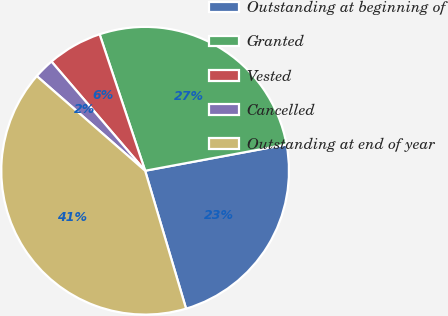<chart> <loc_0><loc_0><loc_500><loc_500><pie_chart><fcel>Outstanding at beginning of<fcel>Granted<fcel>Vested<fcel>Cancelled<fcel>Outstanding at end of year<nl><fcel>23.33%<fcel>27.2%<fcel>6.16%<fcel>2.29%<fcel>41.02%<nl></chart> 